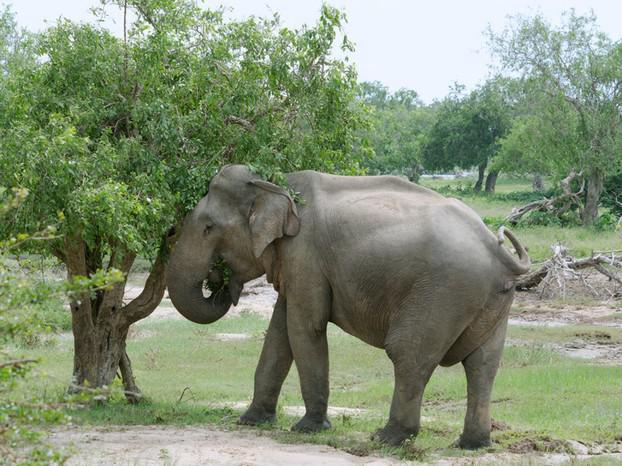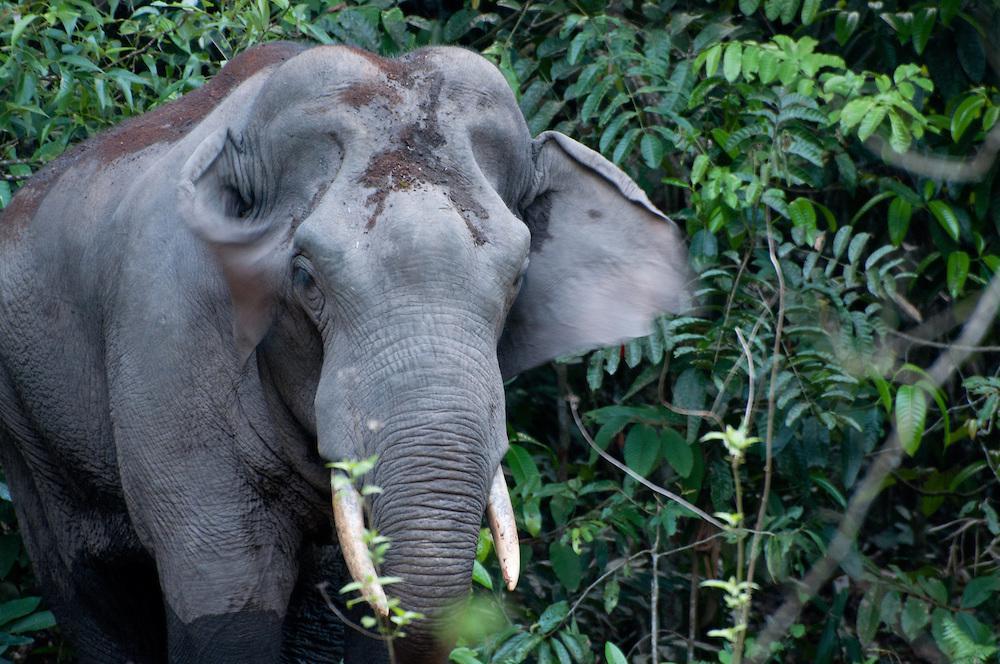The first image is the image on the left, the second image is the image on the right. Assess this claim about the two images: "A leftward-facing elephant has a type of chair strapped to its back.". Correct or not? Answer yes or no. No. The first image is the image on the left, the second image is the image on the right. For the images displayed, is the sentence "A person is riding an elephant that is wading through water." factually correct? Answer yes or no. No. 